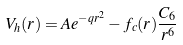Convert formula to latex. <formula><loc_0><loc_0><loc_500><loc_500>V _ { h } ( r ) = A e ^ { - q r ^ { 2 } } - f _ { c } ( r ) \frac { C _ { 6 } } { r ^ { 6 } }</formula> 